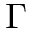Convert formula to latex. <formula><loc_0><loc_0><loc_500><loc_500>\Gamma</formula> 